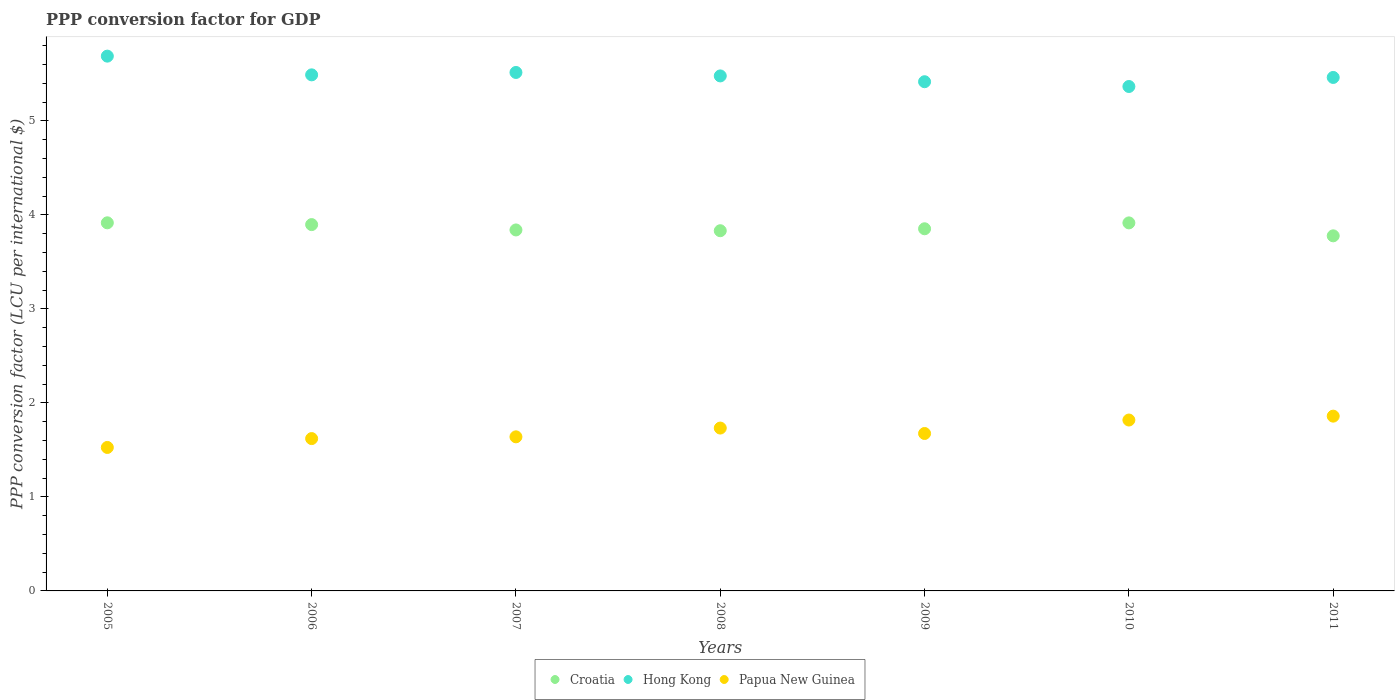What is the PPP conversion factor for GDP in Papua New Guinea in 2006?
Make the answer very short. 1.62. Across all years, what is the maximum PPP conversion factor for GDP in Croatia?
Offer a terse response. 3.92. Across all years, what is the minimum PPP conversion factor for GDP in Hong Kong?
Give a very brief answer. 5.37. In which year was the PPP conversion factor for GDP in Papua New Guinea maximum?
Provide a short and direct response. 2011. What is the total PPP conversion factor for GDP in Papua New Guinea in the graph?
Your answer should be very brief. 11.87. What is the difference between the PPP conversion factor for GDP in Papua New Guinea in 2010 and that in 2011?
Ensure brevity in your answer.  -0.04. What is the difference between the PPP conversion factor for GDP in Papua New Guinea in 2008 and the PPP conversion factor for GDP in Hong Kong in 2007?
Your answer should be very brief. -3.78. What is the average PPP conversion factor for GDP in Papua New Guinea per year?
Provide a succinct answer. 1.7. In the year 2006, what is the difference between the PPP conversion factor for GDP in Croatia and PPP conversion factor for GDP in Papua New Guinea?
Keep it short and to the point. 2.28. In how many years, is the PPP conversion factor for GDP in Hong Kong greater than 3.4 LCU?
Provide a short and direct response. 7. What is the ratio of the PPP conversion factor for GDP in Croatia in 2010 to that in 2011?
Your answer should be very brief. 1.04. Is the PPP conversion factor for GDP in Papua New Guinea in 2006 less than that in 2009?
Give a very brief answer. Yes. What is the difference between the highest and the second highest PPP conversion factor for GDP in Papua New Guinea?
Keep it short and to the point. 0.04. What is the difference between the highest and the lowest PPP conversion factor for GDP in Hong Kong?
Provide a short and direct response. 0.32. Is it the case that in every year, the sum of the PPP conversion factor for GDP in Croatia and PPP conversion factor for GDP in Hong Kong  is greater than the PPP conversion factor for GDP in Papua New Guinea?
Offer a very short reply. Yes. Is the PPP conversion factor for GDP in Croatia strictly less than the PPP conversion factor for GDP in Hong Kong over the years?
Keep it short and to the point. Yes. How many years are there in the graph?
Provide a short and direct response. 7. What is the difference between two consecutive major ticks on the Y-axis?
Provide a short and direct response. 1. Does the graph contain any zero values?
Provide a succinct answer. No. Where does the legend appear in the graph?
Give a very brief answer. Bottom center. How many legend labels are there?
Offer a very short reply. 3. How are the legend labels stacked?
Offer a terse response. Horizontal. What is the title of the graph?
Your response must be concise. PPP conversion factor for GDP. Does "Tajikistan" appear as one of the legend labels in the graph?
Give a very brief answer. No. What is the label or title of the X-axis?
Your response must be concise. Years. What is the label or title of the Y-axis?
Give a very brief answer. PPP conversion factor (LCU per international $). What is the PPP conversion factor (LCU per international $) in Croatia in 2005?
Offer a very short reply. 3.92. What is the PPP conversion factor (LCU per international $) in Hong Kong in 2005?
Your answer should be very brief. 5.69. What is the PPP conversion factor (LCU per international $) in Papua New Guinea in 2005?
Offer a terse response. 1.53. What is the PPP conversion factor (LCU per international $) in Croatia in 2006?
Keep it short and to the point. 3.9. What is the PPP conversion factor (LCU per international $) in Hong Kong in 2006?
Your response must be concise. 5.49. What is the PPP conversion factor (LCU per international $) in Papua New Guinea in 2006?
Keep it short and to the point. 1.62. What is the PPP conversion factor (LCU per international $) in Croatia in 2007?
Give a very brief answer. 3.84. What is the PPP conversion factor (LCU per international $) in Hong Kong in 2007?
Provide a short and direct response. 5.51. What is the PPP conversion factor (LCU per international $) of Papua New Guinea in 2007?
Your answer should be compact. 1.64. What is the PPP conversion factor (LCU per international $) in Croatia in 2008?
Make the answer very short. 3.83. What is the PPP conversion factor (LCU per international $) in Hong Kong in 2008?
Keep it short and to the point. 5.48. What is the PPP conversion factor (LCU per international $) in Papua New Guinea in 2008?
Offer a terse response. 1.73. What is the PPP conversion factor (LCU per international $) of Croatia in 2009?
Make the answer very short. 3.85. What is the PPP conversion factor (LCU per international $) in Hong Kong in 2009?
Your response must be concise. 5.42. What is the PPP conversion factor (LCU per international $) in Papua New Guinea in 2009?
Your answer should be very brief. 1.67. What is the PPP conversion factor (LCU per international $) in Croatia in 2010?
Offer a very short reply. 3.91. What is the PPP conversion factor (LCU per international $) of Hong Kong in 2010?
Ensure brevity in your answer.  5.37. What is the PPP conversion factor (LCU per international $) of Papua New Guinea in 2010?
Offer a terse response. 1.82. What is the PPP conversion factor (LCU per international $) of Croatia in 2011?
Make the answer very short. 3.78. What is the PPP conversion factor (LCU per international $) in Hong Kong in 2011?
Offer a terse response. 5.46. What is the PPP conversion factor (LCU per international $) of Papua New Guinea in 2011?
Offer a very short reply. 1.86. Across all years, what is the maximum PPP conversion factor (LCU per international $) of Croatia?
Give a very brief answer. 3.92. Across all years, what is the maximum PPP conversion factor (LCU per international $) of Hong Kong?
Ensure brevity in your answer.  5.69. Across all years, what is the maximum PPP conversion factor (LCU per international $) of Papua New Guinea?
Your answer should be very brief. 1.86. Across all years, what is the minimum PPP conversion factor (LCU per international $) of Croatia?
Give a very brief answer. 3.78. Across all years, what is the minimum PPP conversion factor (LCU per international $) of Hong Kong?
Your answer should be very brief. 5.37. Across all years, what is the minimum PPP conversion factor (LCU per international $) in Papua New Guinea?
Keep it short and to the point. 1.53. What is the total PPP conversion factor (LCU per international $) of Croatia in the graph?
Provide a short and direct response. 27.03. What is the total PPP conversion factor (LCU per international $) in Hong Kong in the graph?
Make the answer very short. 38.41. What is the total PPP conversion factor (LCU per international $) in Papua New Guinea in the graph?
Provide a short and direct response. 11.87. What is the difference between the PPP conversion factor (LCU per international $) of Croatia in 2005 and that in 2006?
Your answer should be compact. 0.02. What is the difference between the PPP conversion factor (LCU per international $) of Hong Kong in 2005 and that in 2006?
Provide a short and direct response. 0.2. What is the difference between the PPP conversion factor (LCU per international $) of Papua New Guinea in 2005 and that in 2006?
Offer a very short reply. -0.09. What is the difference between the PPP conversion factor (LCU per international $) in Croatia in 2005 and that in 2007?
Give a very brief answer. 0.08. What is the difference between the PPP conversion factor (LCU per international $) in Hong Kong in 2005 and that in 2007?
Make the answer very short. 0.17. What is the difference between the PPP conversion factor (LCU per international $) of Papua New Guinea in 2005 and that in 2007?
Make the answer very short. -0.11. What is the difference between the PPP conversion factor (LCU per international $) in Croatia in 2005 and that in 2008?
Ensure brevity in your answer.  0.08. What is the difference between the PPP conversion factor (LCU per international $) of Hong Kong in 2005 and that in 2008?
Provide a succinct answer. 0.21. What is the difference between the PPP conversion factor (LCU per international $) in Papua New Guinea in 2005 and that in 2008?
Keep it short and to the point. -0.21. What is the difference between the PPP conversion factor (LCU per international $) of Croatia in 2005 and that in 2009?
Make the answer very short. 0.06. What is the difference between the PPP conversion factor (LCU per international $) of Hong Kong in 2005 and that in 2009?
Keep it short and to the point. 0.27. What is the difference between the PPP conversion factor (LCU per international $) of Papua New Guinea in 2005 and that in 2009?
Provide a succinct answer. -0.15. What is the difference between the PPP conversion factor (LCU per international $) of Croatia in 2005 and that in 2010?
Provide a succinct answer. 0. What is the difference between the PPP conversion factor (LCU per international $) in Hong Kong in 2005 and that in 2010?
Give a very brief answer. 0.32. What is the difference between the PPP conversion factor (LCU per international $) of Papua New Guinea in 2005 and that in 2010?
Your answer should be compact. -0.29. What is the difference between the PPP conversion factor (LCU per international $) of Croatia in 2005 and that in 2011?
Give a very brief answer. 0.14. What is the difference between the PPP conversion factor (LCU per international $) in Hong Kong in 2005 and that in 2011?
Provide a succinct answer. 0.23. What is the difference between the PPP conversion factor (LCU per international $) in Papua New Guinea in 2005 and that in 2011?
Your answer should be very brief. -0.33. What is the difference between the PPP conversion factor (LCU per international $) of Croatia in 2006 and that in 2007?
Provide a short and direct response. 0.06. What is the difference between the PPP conversion factor (LCU per international $) in Hong Kong in 2006 and that in 2007?
Your answer should be compact. -0.03. What is the difference between the PPP conversion factor (LCU per international $) of Papua New Guinea in 2006 and that in 2007?
Make the answer very short. -0.02. What is the difference between the PPP conversion factor (LCU per international $) of Croatia in 2006 and that in 2008?
Provide a short and direct response. 0.07. What is the difference between the PPP conversion factor (LCU per international $) of Hong Kong in 2006 and that in 2008?
Offer a very short reply. 0.01. What is the difference between the PPP conversion factor (LCU per international $) of Papua New Guinea in 2006 and that in 2008?
Provide a short and direct response. -0.11. What is the difference between the PPP conversion factor (LCU per international $) of Croatia in 2006 and that in 2009?
Offer a terse response. 0.04. What is the difference between the PPP conversion factor (LCU per international $) of Hong Kong in 2006 and that in 2009?
Your answer should be compact. 0.07. What is the difference between the PPP conversion factor (LCU per international $) in Papua New Guinea in 2006 and that in 2009?
Your response must be concise. -0.05. What is the difference between the PPP conversion factor (LCU per international $) of Croatia in 2006 and that in 2010?
Provide a short and direct response. -0.02. What is the difference between the PPP conversion factor (LCU per international $) in Hong Kong in 2006 and that in 2010?
Provide a short and direct response. 0.12. What is the difference between the PPP conversion factor (LCU per international $) of Papua New Guinea in 2006 and that in 2010?
Give a very brief answer. -0.2. What is the difference between the PPP conversion factor (LCU per international $) of Croatia in 2006 and that in 2011?
Make the answer very short. 0.12. What is the difference between the PPP conversion factor (LCU per international $) of Hong Kong in 2006 and that in 2011?
Ensure brevity in your answer.  0.03. What is the difference between the PPP conversion factor (LCU per international $) of Papua New Guinea in 2006 and that in 2011?
Offer a terse response. -0.24. What is the difference between the PPP conversion factor (LCU per international $) of Croatia in 2007 and that in 2008?
Provide a short and direct response. 0.01. What is the difference between the PPP conversion factor (LCU per international $) in Hong Kong in 2007 and that in 2008?
Your answer should be very brief. 0.04. What is the difference between the PPP conversion factor (LCU per international $) in Papua New Guinea in 2007 and that in 2008?
Your answer should be compact. -0.09. What is the difference between the PPP conversion factor (LCU per international $) of Croatia in 2007 and that in 2009?
Your response must be concise. -0.01. What is the difference between the PPP conversion factor (LCU per international $) of Hong Kong in 2007 and that in 2009?
Make the answer very short. 0.1. What is the difference between the PPP conversion factor (LCU per international $) in Papua New Guinea in 2007 and that in 2009?
Offer a terse response. -0.04. What is the difference between the PPP conversion factor (LCU per international $) in Croatia in 2007 and that in 2010?
Provide a succinct answer. -0.07. What is the difference between the PPP conversion factor (LCU per international $) of Hong Kong in 2007 and that in 2010?
Ensure brevity in your answer.  0.15. What is the difference between the PPP conversion factor (LCU per international $) of Papua New Guinea in 2007 and that in 2010?
Your answer should be compact. -0.18. What is the difference between the PPP conversion factor (LCU per international $) in Croatia in 2007 and that in 2011?
Provide a short and direct response. 0.06. What is the difference between the PPP conversion factor (LCU per international $) of Hong Kong in 2007 and that in 2011?
Give a very brief answer. 0.05. What is the difference between the PPP conversion factor (LCU per international $) of Papua New Guinea in 2007 and that in 2011?
Make the answer very short. -0.22. What is the difference between the PPP conversion factor (LCU per international $) of Croatia in 2008 and that in 2009?
Offer a very short reply. -0.02. What is the difference between the PPP conversion factor (LCU per international $) of Hong Kong in 2008 and that in 2009?
Offer a very short reply. 0.06. What is the difference between the PPP conversion factor (LCU per international $) in Papua New Guinea in 2008 and that in 2009?
Provide a short and direct response. 0.06. What is the difference between the PPP conversion factor (LCU per international $) of Croatia in 2008 and that in 2010?
Provide a short and direct response. -0.08. What is the difference between the PPP conversion factor (LCU per international $) of Hong Kong in 2008 and that in 2010?
Ensure brevity in your answer.  0.11. What is the difference between the PPP conversion factor (LCU per international $) in Papua New Guinea in 2008 and that in 2010?
Your answer should be very brief. -0.09. What is the difference between the PPP conversion factor (LCU per international $) of Croatia in 2008 and that in 2011?
Your answer should be compact. 0.05. What is the difference between the PPP conversion factor (LCU per international $) in Hong Kong in 2008 and that in 2011?
Make the answer very short. 0.02. What is the difference between the PPP conversion factor (LCU per international $) of Papua New Guinea in 2008 and that in 2011?
Your answer should be compact. -0.13. What is the difference between the PPP conversion factor (LCU per international $) in Croatia in 2009 and that in 2010?
Your answer should be very brief. -0.06. What is the difference between the PPP conversion factor (LCU per international $) in Hong Kong in 2009 and that in 2010?
Your answer should be very brief. 0.05. What is the difference between the PPP conversion factor (LCU per international $) of Papua New Guinea in 2009 and that in 2010?
Offer a terse response. -0.14. What is the difference between the PPP conversion factor (LCU per international $) in Croatia in 2009 and that in 2011?
Offer a terse response. 0.07. What is the difference between the PPP conversion factor (LCU per international $) of Hong Kong in 2009 and that in 2011?
Your response must be concise. -0.05. What is the difference between the PPP conversion factor (LCU per international $) in Papua New Guinea in 2009 and that in 2011?
Provide a succinct answer. -0.18. What is the difference between the PPP conversion factor (LCU per international $) of Croatia in 2010 and that in 2011?
Keep it short and to the point. 0.14. What is the difference between the PPP conversion factor (LCU per international $) of Hong Kong in 2010 and that in 2011?
Ensure brevity in your answer.  -0.1. What is the difference between the PPP conversion factor (LCU per international $) of Papua New Guinea in 2010 and that in 2011?
Provide a short and direct response. -0.04. What is the difference between the PPP conversion factor (LCU per international $) of Croatia in 2005 and the PPP conversion factor (LCU per international $) of Hong Kong in 2006?
Offer a terse response. -1.57. What is the difference between the PPP conversion factor (LCU per international $) of Croatia in 2005 and the PPP conversion factor (LCU per international $) of Papua New Guinea in 2006?
Ensure brevity in your answer.  2.3. What is the difference between the PPP conversion factor (LCU per international $) in Hong Kong in 2005 and the PPP conversion factor (LCU per international $) in Papua New Guinea in 2006?
Your answer should be compact. 4.07. What is the difference between the PPP conversion factor (LCU per international $) in Croatia in 2005 and the PPP conversion factor (LCU per international $) in Hong Kong in 2007?
Provide a short and direct response. -1.6. What is the difference between the PPP conversion factor (LCU per international $) of Croatia in 2005 and the PPP conversion factor (LCU per international $) of Papua New Guinea in 2007?
Your answer should be very brief. 2.28. What is the difference between the PPP conversion factor (LCU per international $) of Hong Kong in 2005 and the PPP conversion factor (LCU per international $) of Papua New Guinea in 2007?
Keep it short and to the point. 4.05. What is the difference between the PPP conversion factor (LCU per international $) of Croatia in 2005 and the PPP conversion factor (LCU per international $) of Hong Kong in 2008?
Offer a terse response. -1.56. What is the difference between the PPP conversion factor (LCU per international $) of Croatia in 2005 and the PPP conversion factor (LCU per international $) of Papua New Guinea in 2008?
Provide a succinct answer. 2.18. What is the difference between the PPP conversion factor (LCU per international $) in Hong Kong in 2005 and the PPP conversion factor (LCU per international $) in Papua New Guinea in 2008?
Your answer should be very brief. 3.96. What is the difference between the PPP conversion factor (LCU per international $) in Croatia in 2005 and the PPP conversion factor (LCU per international $) in Hong Kong in 2009?
Give a very brief answer. -1.5. What is the difference between the PPP conversion factor (LCU per international $) of Croatia in 2005 and the PPP conversion factor (LCU per international $) of Papua New Guinea in 2009?
Ensure brevity in your answer.  2.24. What is the difference between the PPP conversion factor (LCU per international $) of Hong Kong in 2005 and the PPP conversion factor (LCU per international $) of Papua New Guinea in 2009?
Provide a short and direct response. 4.01. What is the difference between the PPP conversion factor (LCU per international $) of Croatia in 2005 and the PPP conversion factor (LCU per international $) of Hong Kong in 2010?
Provide a succinct answer. -1.45. What is the difference between the PPP conversion factor (LCU per international $) of Croatia in 2005 and the PPP conversion factor (LCU per international $) of Papua New Guinea in 2010?
Provide a succinct answer. 2.1. What is the difference between the PPP conversion factor (LCU per international $) in Hong Kong in 2005 and the PPP conversion factor (LCU per international $) in Papua New Guinea in 2010?
Provide a short and direct response. 3.87. What is the difference between the PPP conversion factor (LCU per international $) of Croatia in 2005 and the PPP conversion factor (LCU per international $) of Hong Kong in 2011?
Offer a very short reply. -1.55. What is the difference between the PPP conversion factor (LCU per international $) in Croatia in 2005 and the PPP conversion factor (LCU per international $) in Papua New Guinea in 2011?
Your response must be concise. 2.06. What is the difference between the PPP conversion factor (LCU per international $) of Hong Kong in 2005 and the PPP conversion factor (LCU per international $) of Papua New Guinea in 2011?
Offer a very short reply. 3.83. What is the difference between the PPP conversion factor (LCU per international $) in Croatia in 2006 and the PPP conversion factor (LCU per international $) in Hong Kong in 2007?
Your answer should be very brief. -1.62. What is the difference between the PPP conversion factor (LCU per international $) of Croatia in 2006 and the PPP conversion factor (LCU per international $) of Papua New Guinea in 2007?
Keep it short and to the point. 2.26. What is the difference between the PPP conversion factor (LCU per international $) in Hong Kong in 2006 and the PPP conversion factor (LCU per international $) in Papua New Guinea in 2007?
Offer a terse response. 3.85. What is the difference between the PPP conversion factor (LCU per international $) of Croatia in 2006 and the PPP conversion factor (LCU per international $) of Hong Kong in 2008?
Your answer should be compact. -1.58. What is the difference between the PPP conversion factor (LCU per international $) in Croatia in 2006 and the PPP conversion factor (LCU per international $) in Papua New Guinea in 2008?
Your answer should be very brief. 2.16. What is the difference between the PPP conversion factor (LCU per international $) in Hong Kong in 2006 and the PPP conversion factor (LCU per international $) in Papua New Guinea in 2008?
Your response must be concise. 3.76. What is the difference between the PPP conversion factor (LCU per international $) of Croatia in 2006 and the PPP conversion factor (LCU per international $) of Hong Kong in 2009?
Your answer should be compact. -1.52. What is the difference between the PPP conversion factor (LCU per international $) of Croatia in 2006 and the PPP conversion factor (LCU per international $) of Papua New Guinea in 2009?
Make the answer very short. 2.22. What is the difference between the PPP conversion factor (LCU per international $) of Hong Kong in 2006 and the PPP conversion factor (LCU per international $) of Papua New Guinea in 2009?
Give a very brief answer. 3.81. What is the difference between the PPP conversion factor (LCU per international $) of Croatia in 2006 and the PPP conversion factor (LCU per international $) of Hong Kong in 2010?
Make the answer very short. -1.47. What is the difference between the PPP conversion factor (LCU per international $) in Croatia in 2006 and the PPP conversion factor (LCU per international $) in Papua New Guinea in 2010?
Your answer should be very brief. 2.08. What is the difference between the PPP conversion factor (LCU per international $) in Hong Kong in 2006 and the PPP conversion factor (LCU per international $) in Papua New Guinea in 2010?
Your answer should be compact. 3.67. What is the difference between the PPP conversion factor (LCU per international $) in Croatia in 2006 and the PPP conversion factor (LCU per international $) in Hong Kong in 2011?
Keep it short and to the point. -1.57. What is the difference between the PPP conversion factor (LCU per international $) in Croatia in 2006 and the PPP conversion factor (LCU per international $) in Papua New Guinea in 2011?
Provide a succinct answer. 2.04. What is the difference between the PPP conversion factor (LCU per international $) of Hong Kong in 2006 and the PPP conversion factor (LCU per international $) of Papua New Guinea in 2011?
Offer a terse response. 3.63. What is the difference between the PPP conversion factor (LCU per international $) in Croatia in 2007 and the PPP conversion factor (LCU per international $) in Hong Kong in 2008?
Give a very brief answer. -1.64. What is the difference between the PPP conversion factor (LCU per international $) of Croatia in 2007 and the PPP conversion factor (LCU per international $) of Papua New Guinea in 2008?
Provide a short and direct response. 2.11. What is the difference between the PPP conversion factor (LCU per international $) of Hong Kong in 2007 and the PPP conversion factor (LCU per international $) of Papua New Guinea in 2008?
Offer a terse response. 3.78. What is the difference between the PPP conversion factor (LCU per international $) in Croatia in 2007 and the PPP conversion factor (LCU per international $) in Hong Kong in 2009?
Give a very brief answer. -1.58. What is the difference between the PPP conversion factor (LCU per international $) of Croatia in 2007 and the PPP conversion factor (LCU per international $) of Papua New Guinea in 2009?
Offer a very short reply. 2.17. What is the difference between the PPP conversion factor (LCU per international $) in Hong Kong in 2007 and the PPP conversion factor (LCU per international $) in Papua New Guinea in 2009?
Your answer should be compact. 3.84. What is the difference between the PPP conversion factor (LCU per international $) in Croatia in 2007 and the PPP conversion factor (LCU per international $) in Hong Kong in 2010?
Make the answer very short. -1.53. What is the difference between the PPP conversion factor (LCU per international $) of Croatia in 2007 and the PPP conversion factor (LCU per international $) of Papua New Guinea in 2010?
Provide a short and direct response. 2.02. What is the difference between the PPP conversion factor (LCU per international $) of Hong Kong in 2007 and the PPP conversion factor (LCU per international $) of Papua New Guinea in 2010?
Your answer should be compact. 3.7. What is the difference between the PPP conversion factor (LCU per international $) of Croatia in 2007 and the PPP conversion factor (LCU per international $) of Hong Kong in 2011?
Ensure brevity in your answer.  -1.62. What is the difference between the PPP conversion factor (LCU per international $) in Croatia in 2007 and the PPP conversion factor (LCU per international $) in Papua New Guinea in 2011?
Keep it short and to the point. 1.98. What is the difference between the PPP conversion factor (LCU per international $) of Hong Kong in 2007 and the PPP conversion factor (LCU per international $) of Papua New Guinea in 2011?
Offer a terse response. 3.66. What is the difference between the PPP conversion factor (LCU per international $) of Croatia in 2008 and the PPP conversion factor (LCU per international $) of Hong Kong in 2009?
Give a very brief answer. -1.58. What is the difference between the PPP conversion factor (LCU per international $) in Croatia in 2008 and the PPP conversion factor (LCU per international $) in Papua New Guinea in 2009?
Give a very brief answer. 2.16. What is the difference between the PPP conversion factor (LCU per international $) in Hong Kong in 2008 and the PPP conversion factor (LCU per international $) in Papua New Guinea in 2009?
Provide a short and direct response. 3.8. What is the difference between the PPP conversion factor (LCU per international $) in Croatia in 2008 and the PPP conversion factor (LCU per international $) in Hong Kong in 2010?
Your answer should be compact. -1.53. What is the difference between the PPP conversion factor (LCU per international $) of Croatia in 2008 and the PPP conversion factor (LCU per international $) of Papua New Guinea in 2010?
Give a very brief answer. 2.01. What is the difference between the PPP conversion factor (LCU per international $) in Hong Kong in 2008 and the PPP conversion factor (LCU per international $) in Papua New Guinea in 2010?
Your response must be concise. 3.66. What is the difference between the PPP conversion factor (LCU per international $) in Croatia in 2008 and the PPP conversion factor (LCU per international $) in Hong Kong in 2011?
Provide a short and direct response. -1.63. What is the difference between the PPP conversion factor (LCU per international $) of Croatia in 2008 and the PPP conversion factor (LCU per international $) of Papua New Guinea in 2011?
Your answer should be compact. 1.97. What is the difference between the PPP conversion factor (LCU per international $) in Hong Kong in 2008 and the PPP conversion factor (LCU per international $) in Papua New Guinea in 2011?
Offer a very short reply. 3.62. What is the difference between the PPP conversion factor (LCU per international $) in Croatia in 2009 and the PPP conversion factor (LCU per international $) in Hong Kong in 2010?
Your response must be concise. -1.51. What is the difference between the PPP conversion factor (LCU per international $) of Croatia in 2009 and the PPP conversion factor (LCU per international $) of Papua New Guinea in 2010?
Offer a terse response. 2.03. What is the difference between the PPP conversion factor (LCU per international $) in Hong Kong in 2009 and the PPP conversion factor (LCU per international $) in Papua New Guinea in 2010?
Your answer should be compact. 3.6. What is the difference between the PPP conversion factor (LCU per international $) of Croatia in 2009 and the PPP conversion factor (LCU per international $) of Hong Kong in 2011?
Provide a succinct answer. -1.61. What is the difference between the PPP conversion factor (LCU per international $) of Croatia in 2009 and the PPP conversion factor (LCU per international $) of Papua New Guinea in 2011?
Provide a succinct answer. 1.99. What is the difference between the PPP conversion factor (LCU per international $) in Hong Kong in 2009 and the PPP conversion factor (LCU per international $) in Papua New Guinea in 2011?
Your response must be concise. 3.56. What is the difference between the PPP conversion factor (LCU per international $) in Croatia in 2010 and the PPP conversion factor (LCU per international $) in Hong Kong in 2011?
Your answer should be very brief. -1.55. What is the difference between the PPP conversion factor (LCU per international $) of Croatia in 2010 and the PPP conversion factor (LCU per international $) of Papua New Guinea in 2011?
Your answer should be very brief. 2.06. What is the difference between the PPP conversion factor (LCU per international $) of Hong Kong in 2010 and the PPP conversion factor (LCU per international $) of Papua New Guinea in 2011?
Offer a terse response. 3.51. What is the average PPP conversion factor (LCU per international $) of Croatia per year?
Give a very brief answer. 3.86. What is the average PPP conversion factor (LCU per international $) in Hong Kong per year?
Your answer should be very brief. 5.49. What is the average PPP conversion factor (LCU per international $) of Papua New Guinea per year?
Your response must be concise. 1.7. In the year 2005, what is the difference between the PPP conversion factor (LCU per international $) in Croatia and PPP conversion factor (LCU per international $) in Hong Kong?
Make the answer very short. -1.77. In the year 2005, what is the difference between the PPP conversion factor (LCU per international $) of Croatia and PPP conversion factor (LCU per international $) of Papua New Guinea?
Offer a very short reply. 2.39. In the year 2005, what is the difference between the PPP conversion factor (LCU per international $) in Hong Kong and PPP conversion factor (LCU per international $) in Papua New Guinea?
Your answer should be very brief. 4.16. In the year 2006, what is the difference between the PPP conversion factor (LCU per international $) of Croatia and PPP conversion factor (LCU per international $) of Hong Kong?
Your answer should be very brief. -1.59. In the year 2006, what is the difference between the PPP conversion factor (LCU per international $) in Croatia and PPP conversion factor (LCU per international $) in Papua New Guinea?
Your answer should be very brief. 2.28. In the year 2006, what is the difference between the PPP conversion factor (LCU per international $) of Hong Kong and PPP conversion factor (LCU per international $) of Papua New Guinea?
Keep it short and to the point. 3.87. In the year 2007, what is the difference between the PPP conversion factor (LCU per international $) of Croatia and PPP conversion factor (LCU per international $) of Hong Kong?
Provide a succinct answer. -1.68. In the year 2007, what is the difference between the PPP conversion factor (LCU per international $) of Croatia and PPP conversion factor (LCU per international $) of Papua New Guinea?
Give a very brief answer. 2.2. In the year 2007, what is the difference between the PPP conversion factor (LCU per international $) of Hong Kong and PPP conversion factor (LCU per international $) of Papua New Guinea?
Your response must be concise. 3.88. In the year 2008, what is the difference between the PPP conversion factor (LCU per international $) in Croatia and PPP conversion factor (LCU per international $) in Hong Kong?
Your answer should be very brief. -1.65. In the year 2008, what is the difference between the PPP conversion factor (LCU per international $) in Croatia and PPP conversion factor (LCU per international $) in Papua New Guinea?
Your response must be concise. 2.1. In the year 2008, what is the difference between the PPP conversion factor (LCU per international $) in Hong Kong and PPP conversion factor (LCU per international $) in Papua New Guinea?
Provide a short and direct response. 3.75. In the year 2009, what is the difference between the PPP conversion factor (LCU per international $) in Croatia and PPP conversion factor (LCU per international $) in Hong Kong?
Your response must be concise. -1.56. In the year 2009, what is the difference between the PPP conversion factor (LCU per international $) of Croatia and PPP conversion factor (LCU per international $) of Papua New Guinea?
Make the answer very short. 2.18. In the year 2009, what is the difference between the PPP conversion factor (LCU per international $) in Hong Kong and PPP conversion factor (LCU per international $) in Papua New Guinea?
Offer a very short reply. 3.74. In the year 2010, what is the difference between the PPP conversion factor (LCU per international $) in Croatia and PPP conversion factor (LCU per international $) in Hong Kong?
Provide a short and direct response. -1.45. In the year 2010, what is the difference between the PPP conversion factor (LCU per international $) of Croatia and PPP conversion factor (LCU per international $) of Papua New Guinea?
Your answer should be very brief. 2.1. In the year 2010, what is the difference between the PPP conversion factor (LCU per international $) in Hong Kong and PPP conversion factor (LCU per international $) in Papua New Guinea?
Your answer should be very brief. 3.55. In the year 2011, what is the difference between the PPP conversion factor (LCU per international $) in Croatia and PPP conversion factor (LCU per international $) in Hong Kong?
Your answer should be compact. -1.68. In the year 2011, what is the difference between the PPP conversion factor (LCU per international $) in Croatia and PPP conversion factor (LCU per international $) in Papua New Guinea?
Your answer should be compact. 1.92. In the year 2011, what is the difference between the PPP conversion factor (LCU per international $) in Hong Kong and PPP conversion factor (LCU per international $) in Papua New Guinea?
Make the answer very short. 3.6. What is the ratio of the PPP conversion factor (LCU per international $) in Hong Kong in 2005 to that in 2006?
Ensure brevity in your answer.  1.04. What is the ratio of the PPP conversion factor (LCU per international $) of Papua New Guinea in 2005 to that in 2006?
Provide a short and direct response. 0.94. What is the ratio of the PPP conversion factor (LCU per international $) of Croatia in 2005 to that in 2007?
Provide a succinct answer. 1.02. What is the ratio of the PPP conversion factor (LCU per international $) in Hong Kong in 2005 to that in 2007?
Provide a short and direct response. 1.03. What is the ratio of the PPP conversion factor (LCU per international $) of Papua New Guinea in 2005 to that in 2007?
Offer a terse response. 0.93. What is the ratio of the PPP conversion factor (LCU per international $) in Croatia in 2005 to that in 2008?
Give a very brief answer. 1.02. What is the ratio of the PPP conversion factor (LCU per international $) of Hong Kong in 2005 to that in 2008?
Your response must be concise. 1.04. What is the ratio of the PPP conversion factor (LCU per international $) in Papua New Guinea in 2005 to that in 2008?
Your response must be concise. 0.88. What is the ratio of the PPP conversion factor (LCU per international $) of Croatia in 2005 to that in 2009?
Offer a very short reply. 1.02. What is the ratio of the PPP conversion factor (LCU per international $) of Hong Kong in 2005 to that in 2009?
Provide a succinct answer. 1.05. What is the ratio of the PPP conversion factor (LCU per international $) in Papua New Guinea in 2005 to that in 2009?
Your response must be concise. 0.91. What is the ratio of the PPP conversion factor (LCU per international $) of Croatia in 2005 to that in 2010?
Your response must be concise. 1. What is the ratio of the PPP conversion factor (LCU per international $) of Hong Kong in 2005 to that in 2010?
Keep it short and to the point. 1.06. What is the ratio of the PPP conversion factor (LCU per international $) of Papua New Guinea in 2005 to that in 2010?
Keep it short and to the point. 0.84. What is the ratio of the PPP conversion factor (LCU per international $) of Croatia in 2005 to that in 2011?
Offer a very short reply. 1.04. What is the ratio of the PPP conversion factor (LCU per international $) of Hong Kong in 2005 to that in 2011?
Offer a very short reply. 1.04. What is the ratio of the PPP conversion factor (LCU per international $) in Papua New Guinea in 2005 to that in 2011?
Make the answer very short. 0.82. What is the ratio of the PPP conversion factor (LCU per international $) in Croatia in 2006 to that in 2007?
Make the answer very short. 1.01. What is the ratio of the PPP conversion factor (LCU per international $) in Croatia in 2006 to that in 2008?
Provide a succinct answer. 1.02. What is the ratio of the PPP conversion factor (LCU per international $) of Papua New Guinea in 2006 to that in 2008?
Provide a succinct answer. 0.94. What is the ratio of the PPP conversion factor (LCU per international $) in Croatia in 2006 to that in 2009?
Provide a succinct answer. 1.01. What is the ratio of the PPP conversion factor (LCU per international $) of Hong Kong in 2006 to that in 2009?
Ensure brevity in your answer.  1.01. What is the ratio of the PPP conversion factor (LCU per international $) of Papua New Guinea in 2006 to that in 2009?
Your answer should be compact. 0.97. What is the ratio of the PPP conversion factor (LCU per international $) of Croatia in 2006 to that in 2010?
Provide a succinct answer. 1. What is the ratio of the PPP conversion factor (LCU per international $) in Hong Kong in 2006 to that in 2010?
Your response must be concise. 1.02. What is the ratio of the PPP conversion factor (LCU per international $) of Papua New Guinea in 2006 to that in 2010?
Offer a terse response. 0.89. What is the ratio of the PPP conversion factor (LCU per international $) of Croatia in 2006 to that in 2011?
Ensure brevity in your answer.  1.03. What is the ratio of the PPP conversion factor (LCU per international $) in Papua New Guinea in 2006 to that in 2011?
Your answer should be compact. 0.87. What is the ratio of the PPP conversion factor (LCU per international $) in Hong Kong in 2007 to that in 2008?
Provide a succinct answer. 1.01. What is the ratio of the PPP conversion factor (LCU per international $) of Papua New Guinea in 2007 to that in 2008?
Keep it short and to the point. 0.95. What is the ratio of the PPP conversion factor (LCU per international $) of Hong Kong in 2007 to that in 2009?
Make the answer very short. 1.02. What is the ratio of the PPP conversion factor (LCU per international $) of Papua New Guinea in 2007 to that in 2009?
Provide a short and direct response. 0.98. What is the ratio of the PPP conversion factor (LCU per international $) in Croatia in 2007 to that in 2010?
Keep it short and to the point. 0.98. What is the ratio of the PPP conversion factor (LCU per international $) in Hong Kong in 2007 to that in 2010?
Provide a short and direct response. 1.03. What is the ratio of the PPP conversion factor (LCU per international $) of Papua New Guinea in 2007 to that in 2010?
Ensure brevity in your answer.  0.9. What is the ratio of the PPP conversion factor (LCU per international $) of Croatia in 2007 to that in 2011?
Offer a terse response. 1.02. What is the ratio of the PPP conversion factor (LCU per international $) in Hong Kong in 2007 to that in 2011?
Your answer should be very brief. 1.01. What is the ratio of the PPP conversion factor (LCU per international $) in Papua New Guinea in 2007 to that in 2011?
Ensure brevity in your answer.  0.88. What is the ratio of the PPP conversion factor (LCU per international $) of Croatia in 2008 to that in 2009?
Give a very brief answer. 0.99. What is the ratio of the PPP conversion factor (LCU per international $) of Hong Kong in 2008 to that in 2009?
Keep it short and to the point. 1.01. What is the ratio of the PPP conversion factor (LCU per international $) of Papua New Guinea in 2008 to that in 2009?
Keep it short and to the point. 1.03. What is the ratio of the PPP conversion factor (LCU per international $) of Croatia in 2008 to that in 2010?
Provide a succinct answer. 0.98. What is the ratio of the PPP conversion factor (LCU per international $) of Papua New Guinea in 2008 to that in 2010?
Your answer should be very brief. 0.95. What is the ratio of the PPP conversion factor (LCU per international $) of Croatia in 2008 to that in 2011?
Provide a short and direct response. 1.01. What is the ratio of the PPP conversion factor (LCU per international $) of Hong Kong in 2008 to that in 2011?
Provide a succinct answer. 1. What is the ratio of the PPP conversion factor (LCU per international $) of Papua New Guinea in 2008 to that in 2011?
Provide a short and direct response. 0.93. What is the ratio of the PPP conversion factor (LCU per international $) of Croatia in 2009 to that in 2010?
Make the answer very short. 0.98. What is the ratio of the PPP conversion factor (LCU per international $) of Hong Kong in 2009 to that in 2010?
Your response must be concise. 1.01. What is the ratio of the PPP conversion factor (LCU per international $) in Papua New Guinea in 2009 to that in 2010?
Ensure brevity in your answer.  0.92. What is the ratio of the PPP conversion factor (LCU per international $) of Croatia in 2009 to that in 2011?
Provide a succinct answer. 1.02. What is the ratio of the PPP conversion factor (LCU per international $) of Papua New Guinea in 2009 to that in 2011?
Your answer should be compact. 0.9. What is the ratio of the PPP conversion factor (LCU per international $) of Croatia in 2010 to that in 2011?
Ensure brevity in your answer.  1.04. What is the ratio of the PPP conversion factor (LCU per international $) in Hong Kong in 2010 to that in 2011?
Offer a very short reply. 0.98. What is the ratio of the PPP conversion factor (LCU per international $) in Papua New Guinea in 2010 to that in 2011?
Provide a succinct answer. 0.98. What is the difference between the highest and the second highest PPP conversion factor (LCU per international $) in Croatia?
Provide a succinct answer. 0. What is the difference between the highest and the second highest PPP conversion factor (LCU per international $) of Hong Kong?
Your answer should be very brief. 0.17. What is the difference between the highest and the second highest PPP conversion factor (LCU per international $) in Papua New Guinea?
Your response must be concise. 0.04. What is the difference between the highest and the lowest PPP conversion factor (LCU per international $) in Croatia?
Provide a succinct answer. 0.14. What is the difference between the highest and the lowest PPP conversion factor (LCU per international $) of Hong Kong?
Provide a short and direct response. 0.32. What is the difference between the highest and the lowest PPP conversion factor (LCU per international $) of Papua New Guinea?
Your response must be concise. 0.33. 